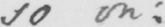Please provide the text content of this handwritten line. so on : 